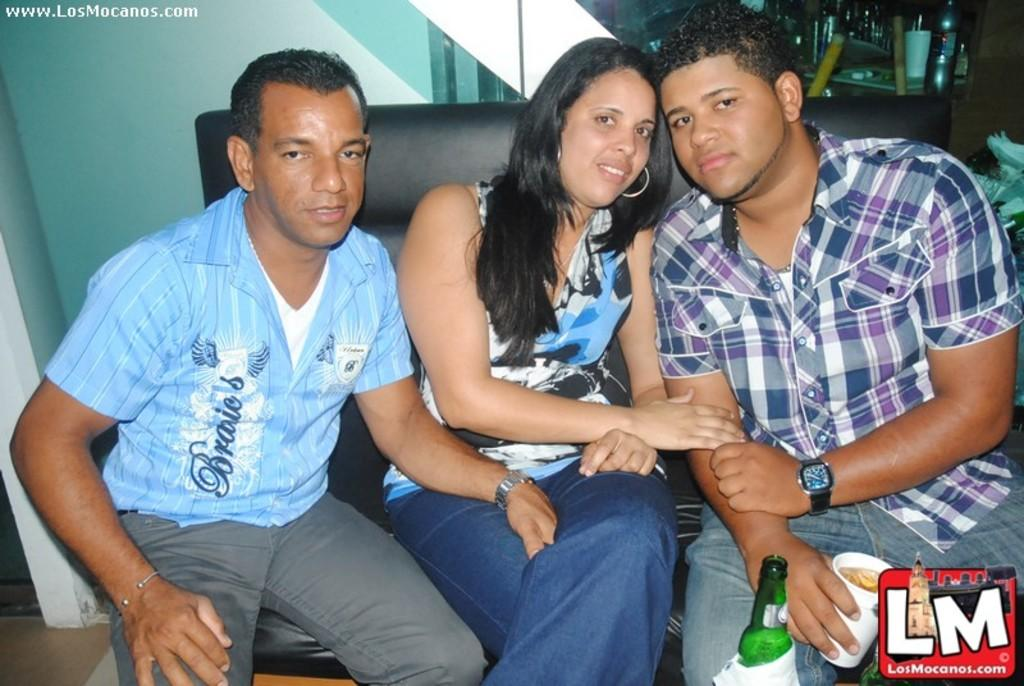<image>
Describe the image concisely. Three people sit on a chair with LM in a red box in the right lower corner. 